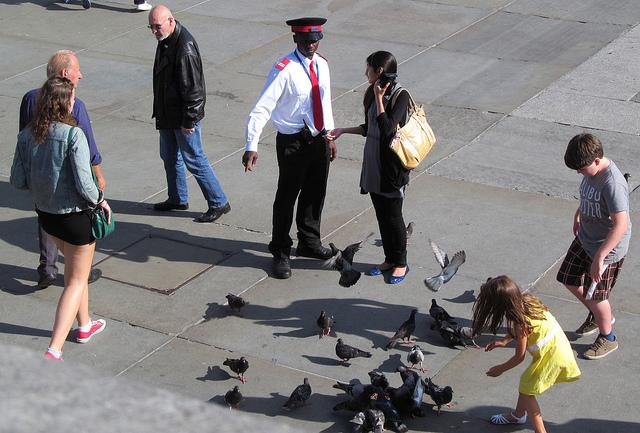What does the girl in yellow do to the birds? Please explain your reasoning. feed them. The girls is crouched around birds that are gathering. 